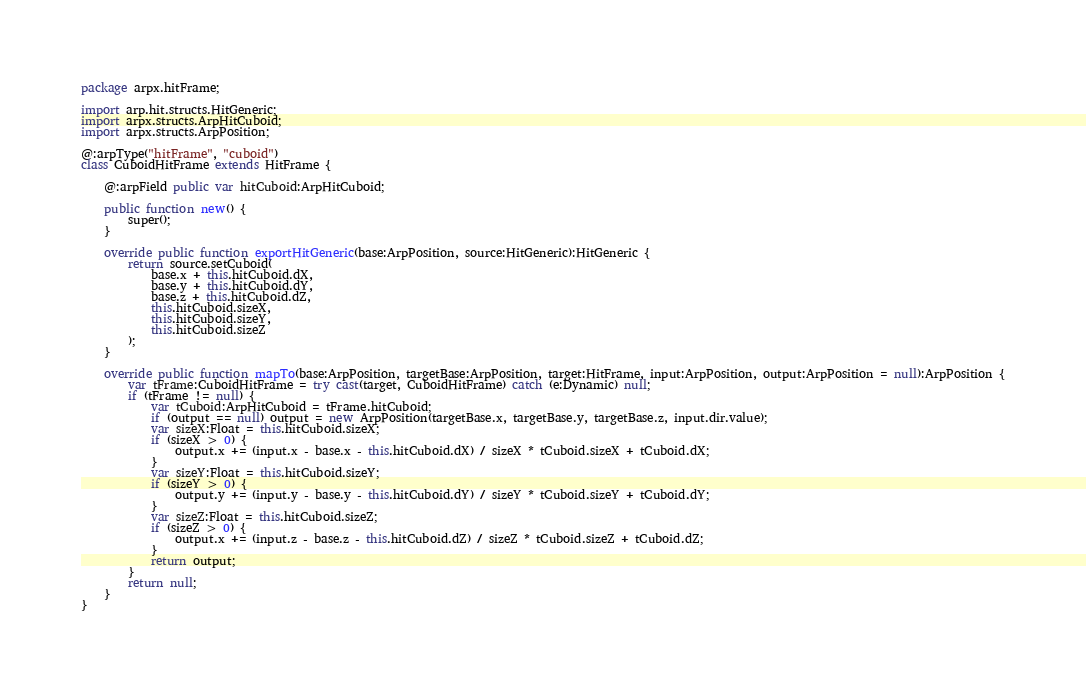<code> <loc_0><loc_0><loc_500><loc_500><_Haxe_>package arpx.hitFrame;

import arp.hit.structs.HitGeneric;
import arpx.structs.ArpHitCuboid;
import arpx.structs.ArpPosition;

@:arpType("hitFrame", "cuboid")
class CuboidHitFrame extends HitFrame {

	@:arpField public var hitCuboid:ArpHitCuboid;

	public function new() {
		super();
	}

	override public function exportHitGeneric(base:ArpPosition, source:HitGeneric):HitGeneric {
		return source.setCuboid(
			base.x + this.hitCuboid.dX,
			base.y + this.hitCuboid.dY,
			base.z + this.hitCuboid.dZ,
			this.hitCuboid.sizeX,
			this.hitCuboid.sizeY,
			this.hitCuboid.sizeZ
		);
	}

	override public function mapTo(base:ArpPosition, targetBase:ArpPosition, target:HitFrame, input:ArpPosition, output:ArpPosition = null):ArpPosition {
		var tFrame:CuboidHitFrame = try cast(target, CuboidHitFrame) catch (e:Dynamic) null;
		if (tFrame != null) {
			var tCuboid:ArpHitCuboid = tFrame.hitCuboid;
			if (output == null) output = new ArpPosition(targetBase.x, targetBase.y, targetBase.z, input.dir.value);
			var sizeX:Float = this.hitCuboid.sizeX;
			if (sizeX > 0) {
				output.x += (input.x - base.x - this.hitCuboid.dX) / sizeX * tCuboid.sizeX + tCuboid.dX;
			}
			var sizeY:Float = this.hitCuboid.sizeY;
			if (sizeY > 0) {
				output.y += (input.y - base.y - this.hitCuboid.dY) / sizeY * tCuboid.sizeY + tCuboid.dY;
			}
			var sizeZ:Float = this.hitCuboid.sizeZ;
			if (sizeZ > 0) {
				output.x += (input.z - base.z - this.hitCuboid.dZ) / sizeZ * tCuboid.sizeZ + tCuboid.dZ;
			}
			return output;
		}
		return null;
	}
}


</code> 